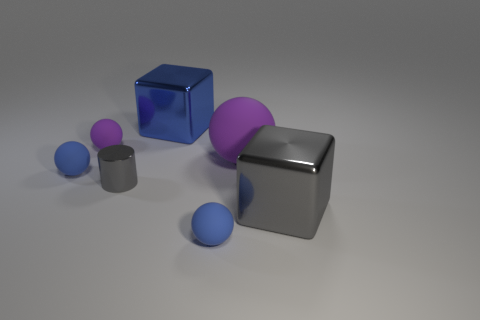Add 1 big purple matte things. How many objects exist? 8 Subtract all cylinders. How many objects are left? 6 Add 2 matte objects. How many matte objects are left? 6 Add 2 tiny metal cylinders. How many tiny metal cylinders exist? 3 Subtract 0 cyan cylinders. How many objects are left? 7 Subtract all big cyan things. Subtract all balls. How many objects are left? 3 